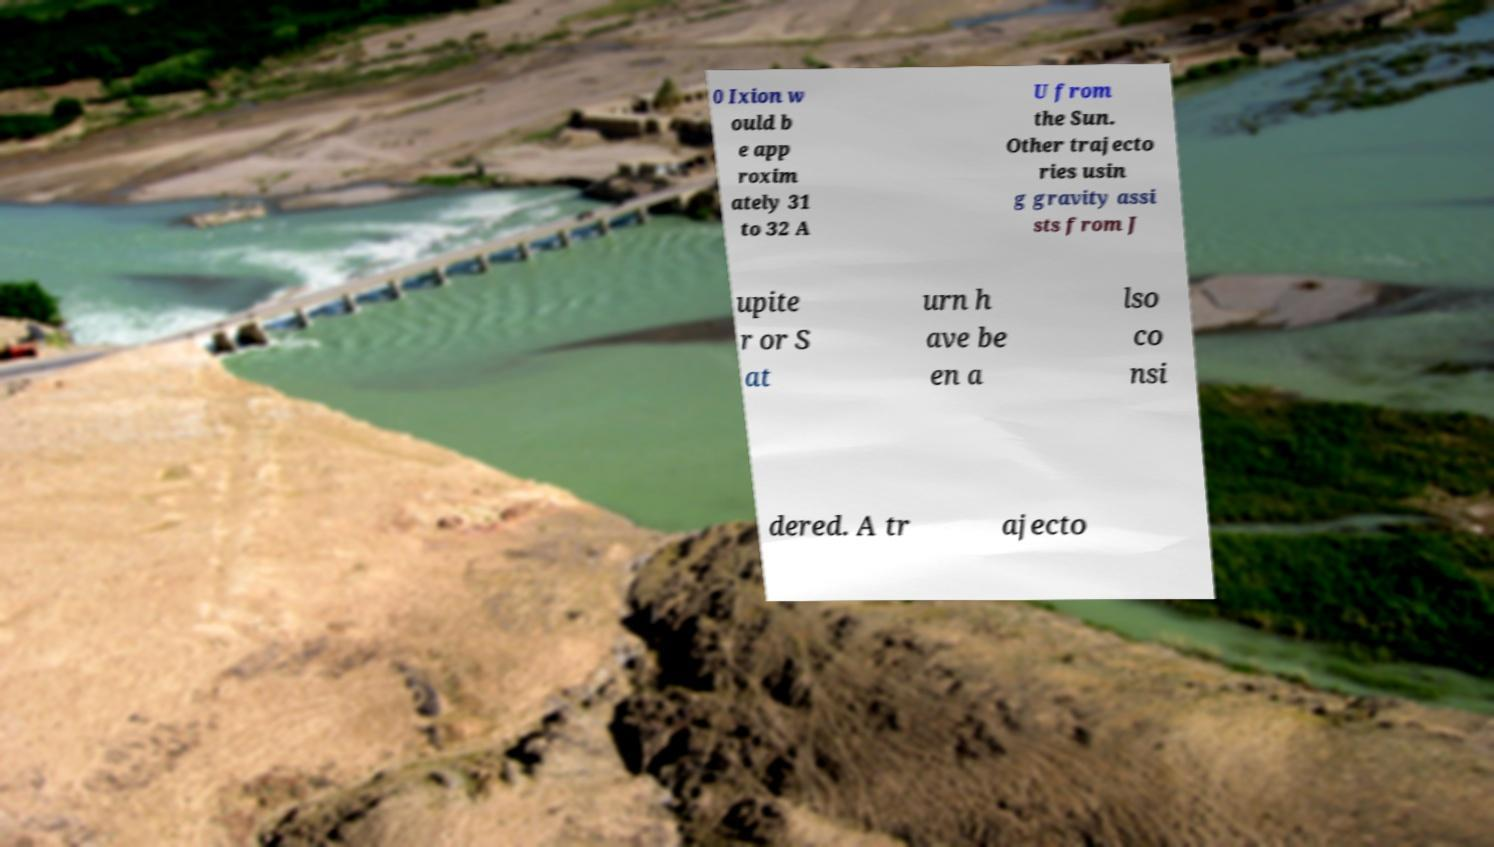Could you extract and type out the text from this image? 0 Ixion w ould b e app roxim ately 31 to 32 A U from the Sun. Other trajecto ries usin g gravity assi sts from J upite r or S at urn h ave be en a lso co nsi dered. A tr ajecto 